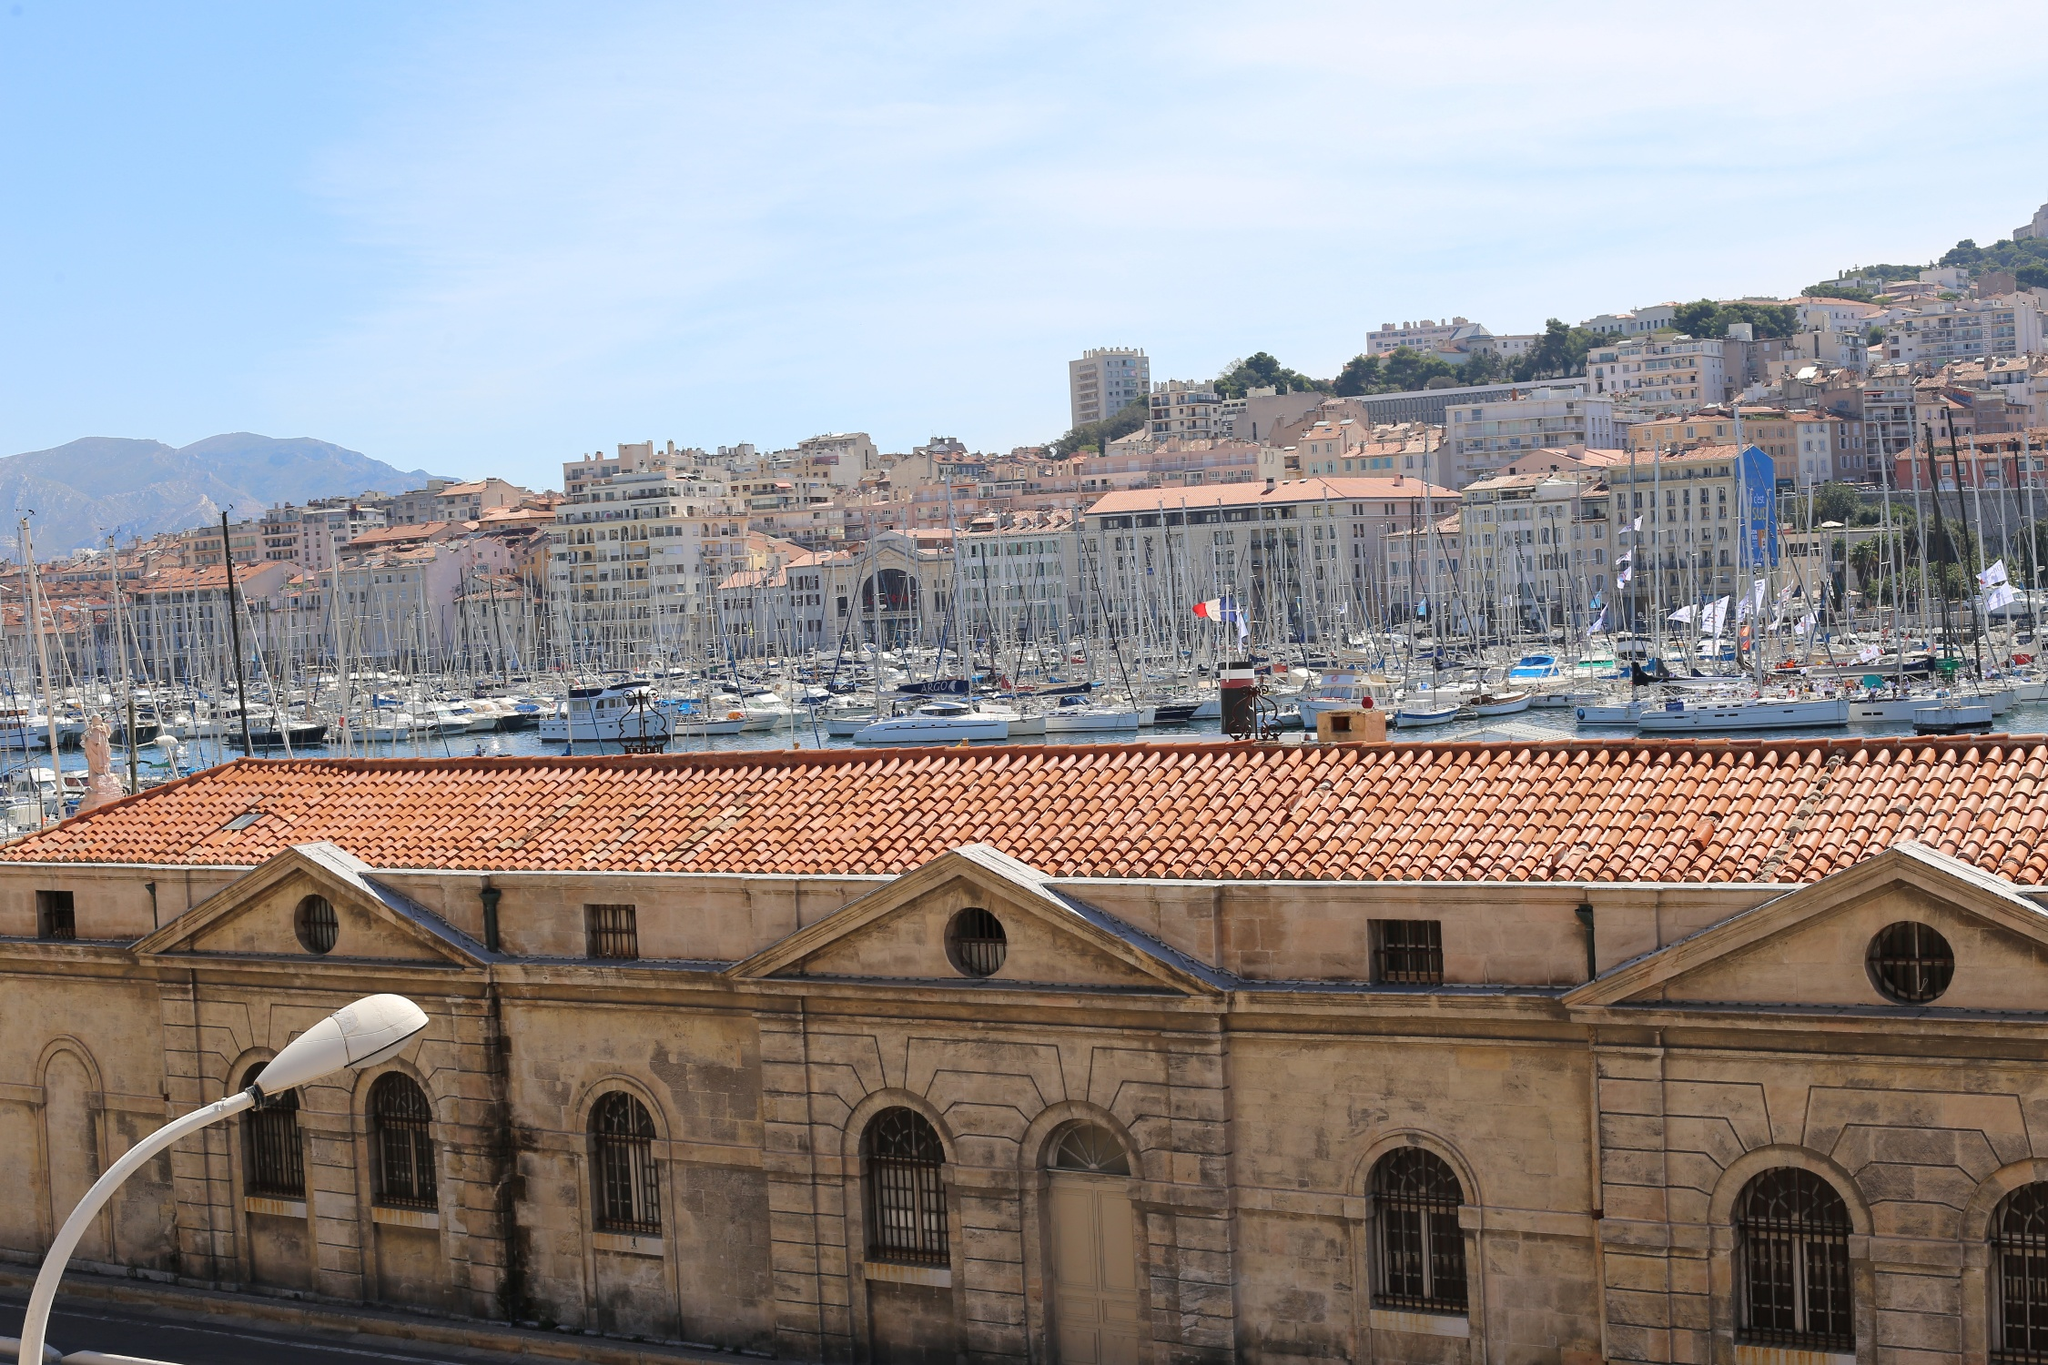Describe the atmosphere of the Old Port of Marseille as depicted in the image. The atmosphere in the image of the Old Port of Marseille is lively and vibrant. The sunny day enhances the brightness, making the water sparkle with reflections from the sky. The port is filled with an array of boats, from small sailboats to larger yachts, illustrating the bustling activity. The charming cityscape and the historic buildings surrounding the port add a sense of warmth and historical richness. You can almost hear the sounds of the city – the gentle hum of boat engines, the distant chatter of people, and the occasional call of seagulls. The overall feeling is one of animated yet serene vitality, blending maritime culture with Mediterranean allure. 